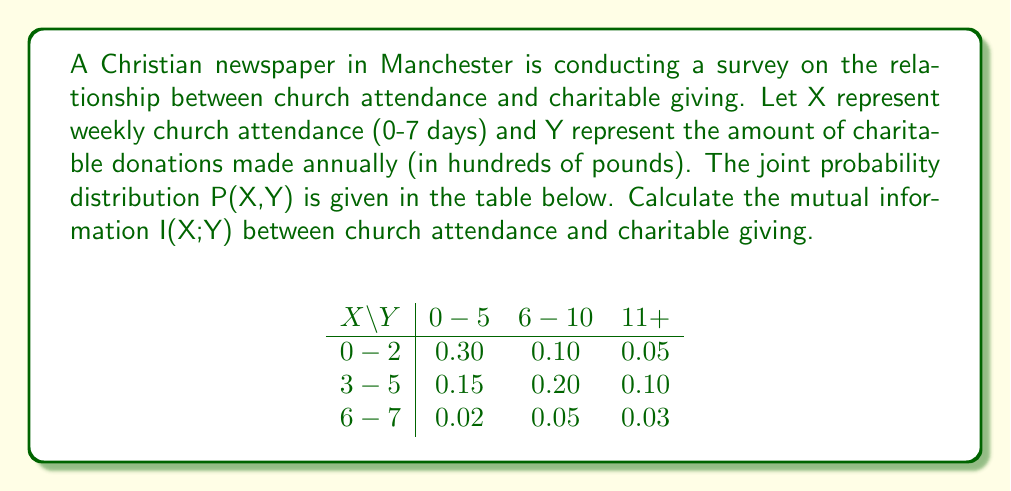Solve this math problem. To calculate the mutual information I(X;Y), we need to follow these steps:

1. Calculate the marginal probabilities P(X) and P(Y).
2. Calculate the entropies H(X) and H(Y).
3. Calculate the joint entropy H(X,Y).
4. Use the formula: I(X;Y) = H(X) + H(Y) - H(X,Y).

Step 1: Marginal probabilities

P(X = 0-2) = 0.30 + 0.10 + 0.05 = 0.45
P(X = 3-5) = 0.15 + 0.20 + 0.10 = 0.45
P(X = 6-7) = 0.02 + 0.05 + 0.03 = 0.10

P(Y = 0-5) = 0.30 + 0.15 + 0.02 = 0.47
P(Y = 6-10) = 0.10 + 0.20 + 0.05 = 0.35
P(Y = 11+) = 0.05 + 0.10 + 0.03 = 0.18

Step 2: Entropies

$$H(X) = -\sum_{x} P(X=x) \log_2 P(X=x)$$
$$H(X) = -[0.45 \log_2 0.45 + 0.45 \log_2 0.45 + 0.10 \log_2 0.10] = 1.36 \text{ bits}$$

$$H(Y) = -\sum_{y} P(Y=y) \log_2 P(Y=y)$$
$$H(Y) = -[0.47 \log_2 0.47 + 0.35 \log_2 0.35 + 0.18 \log_2 0.18] = 1.48 \text{ bits}$$

Step 3: Joint entropy

$$H(X,Y) = -\sum_{x,y} P(X=x, Y=y) \log_2 P(X=x, Y=y)$$
$$H(X,Y) = -[0.30 \log_2 0.30 + 0.10 \log_2 0.10 + ... + 0.03 \log_2 0.03] = 2.71 \text{ bits}$$

Step 4: Mutual information

$$I(X;Y) = H(X) + H(Y) - H(X,Y)$$
$$I(X;Y) = 1.36 + 1.48 - 2.71 = 0.13 \text{ bits}$$
Answer: The mutual information I(X;Y) between church attendance and charitable giving is 0.13 bits. 